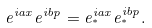<formula> <loc_0><loc_0><loc_500><loc_500>e ^ { i a x } e ^ { i b p } = e _ { ^ { * } } ^ { i a x } e _ { ^ { * } } ^ { i b p } .</formula> 